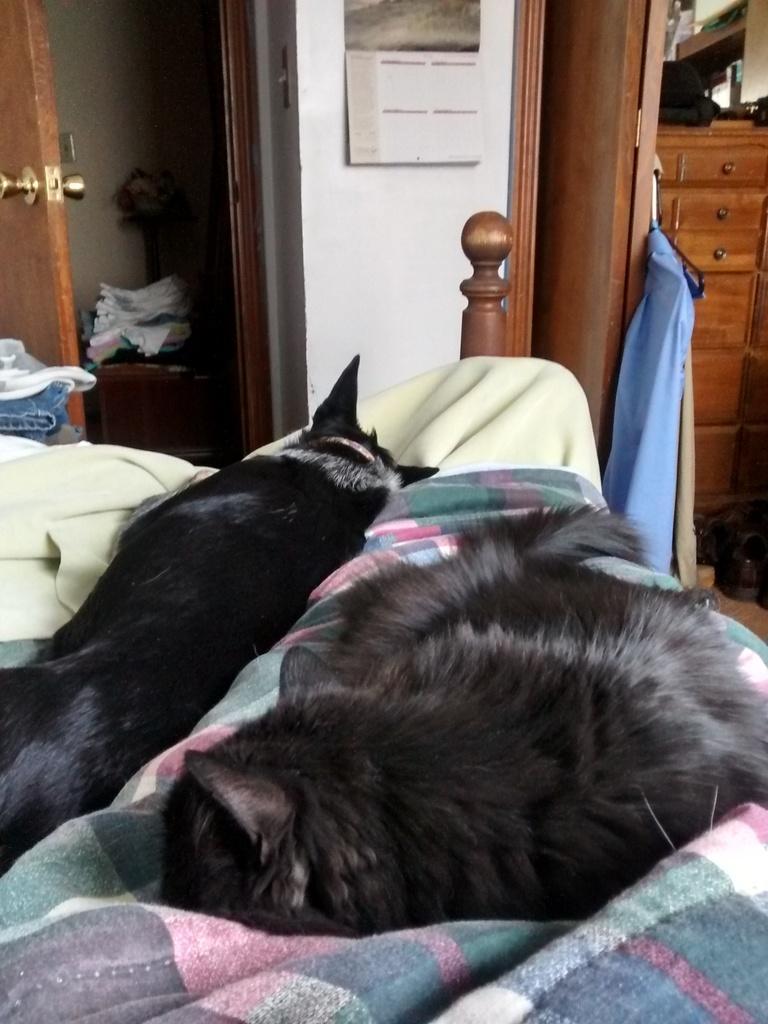Please provide a concise description of this image. this is a picture of a room in this picture there are two dogs sleeping on a bed with the blanket , there is a cupboard near to the door,we can see a calendar on the wall,we can see some clothes which are placed on the table. 